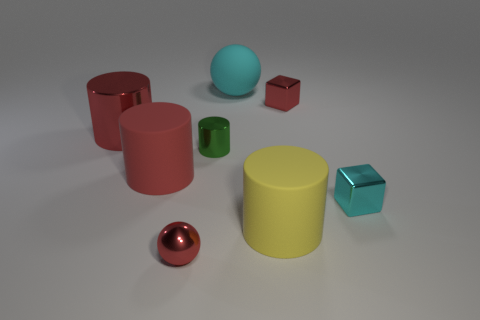What is the material of the small red ball?
Offer a terse response. Metal. What material is the cube that is the same color as the small shiny sphere?
Ensure brevity in your answer.  Metal. There is a small red object behind the large yellow matte cylinder; does it have the same shape as the big cyan rubber object?
Give a very brief answer. No. How many objects are tiny blocks or cyan objects?
Make the answer very short. 3. Does the large thing that is on the right side of the big cyan rubber ball have the same material as the red cube?
Your response must be concise. No. How big is the cyan metallic object?
Give a very brief answer. Small. There is a small shiny thing that is the same color as the large rubber sphere; what shape is it?
Your response must be concise. Cube. What number of cylinders are either tiny shiny things or tiny red things?
Make the answer very short. 1. Is the number of big things in front of the large red rubber cylinder the same as the number of small red things behind the big yellow matte thing?
Your answer should be compact. Yes. The other object that is the same shape as the cyan matte thing is what size?
Your answer should be very brief. Small. 